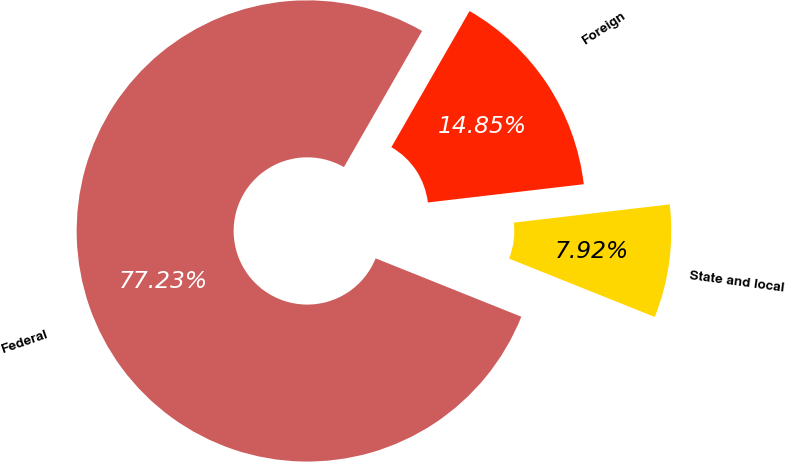Convert chart to OTSL. <chart><loc_0><loc_0><loc_500><loc_500><pie_chart><fcel>Federal<fcel>State and local<fcel>Foreign<nl><fcel>77.23%<fcel>7.92%<fcel>14.85%<nl></chart> 